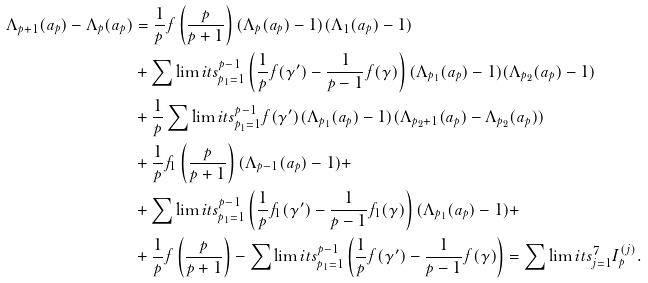<formula> <loc_0><loc_0><loc_500><loc_500>\Lambda _ { p + 1 } ( a _ { p } ) - \Lambda _ { p } ( a _ { p } ) & = \frac { 1 } { p } f \left ( \frac { p } { p + 1 } \right ) ( \Lambda _ { p } ( a _ { p } ) - 1 ) ( \Lambda _ { 1 } ( a _ { p } ) - 1 ) \\ & + \sum \lim i t s _ { p _ { 1 } = 1 } ^ { p - 1 } \left ( \frac { 1 } { p } f ( \gamma ^ { \prime } ) - \frac { 1 } { p - 1 } f ( \gamma ) \right ) ( \Lambda _ { p _ { 1 } } ( a _ { p } ) - 1 ) ( \Lambda _ { p _ { 2 } } ( a _ { p } ) - 1 ) \\ & + \frac { 1 } { p } \sum \lim i t s _ { p _ { 1 } = 1 } ^ { p - 1 } f ( \gamma ^ { \prime } ) ( \Lambda _ { p _ { 1 } } ( a _ { p } ) - 1 ) ( \Lambda _ { p _ { 2 } + 1 } ( a _ { p } ) - \Lambda _ { p _ { 2 } } ( a _ { p } ) ) \\ & + \frac { 1 } { p } f _ { 1 } \left ( \frac { p } { p + 1 } \right ) ( \Lambda _ { p - 1 } ( a _ { p } ) - 1 ) + \\ & + \sum \lim i t s _ { p _ { 1 } = 1 } ^ { p - 1 } \left ( \frac { 1 } { p } f _ { 1 } ( \gamma ^ { \prime } ) - \frac { 1 } { p - 1 } f _ { 1 } ( \gamma ) \right ) ( \Lambda _ { p _ { 1 } } ( a _ { p } ) - 1 ) + \\ & + \frac { 1 } { p } f \left ( \frac { p } { p + 1 } \right ) - \sum \lim i t s _ { p _ { 1 } = 1 } ^ { p - 1 } \left ( \frac { 1 } { p } f ( \gamma ^ { \prime } ) - \frac { 1 } { p - 1 } f ( \gamma ) \right ) = \sum \lim i t s _ { j = 1 } ^ { 7 } I _ { p } ^ { ( j ) } .</formula> 